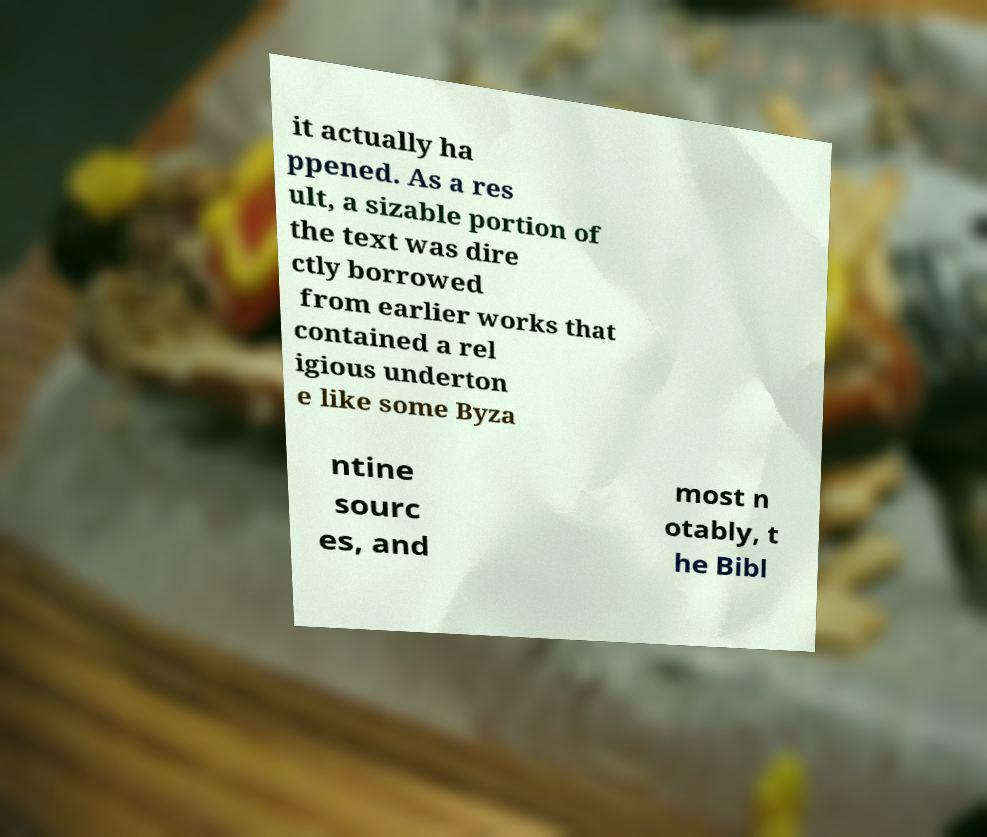For documentation purposes, I need the text within this image transcribed. Could you provide that? it actually ha ppened. As a res ult, a sizable portion of the text was dire ctly borrowed from earlier works that contained a rel igious underton e like some Byza ntine sourc es, and most n otably, t he Bibl 